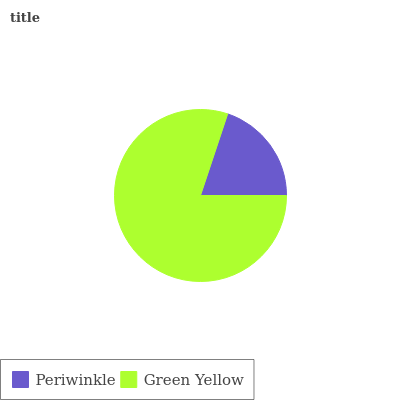Is Periwinkle the minimum?
Answer yes or no. Yes. Is Green Yellow the maximum?
Answer yes or no. Yes. Is Green Yellow the minimum?
Answer yes or no. No. Is Green Yellow greater than Periwinkle?
Answer yes or no. Yes. Is Periwinkle less than Green Yellow?
Answer yes or no. Yes. Is Periwinkle greater than Green Yellow?
Answer yes or no. No. Is Green Yellow less than Periwinkle?
Answer yes or no. No. Is Green Yellow the high median?
Answer yes or no. Yes. Is Periwinkle the low median?
Answer yes or no. Yes. Is Periwinkle the high median?
Answer yes or no. No. Is Green Yellow the low median?
Answer yes or no. No. 